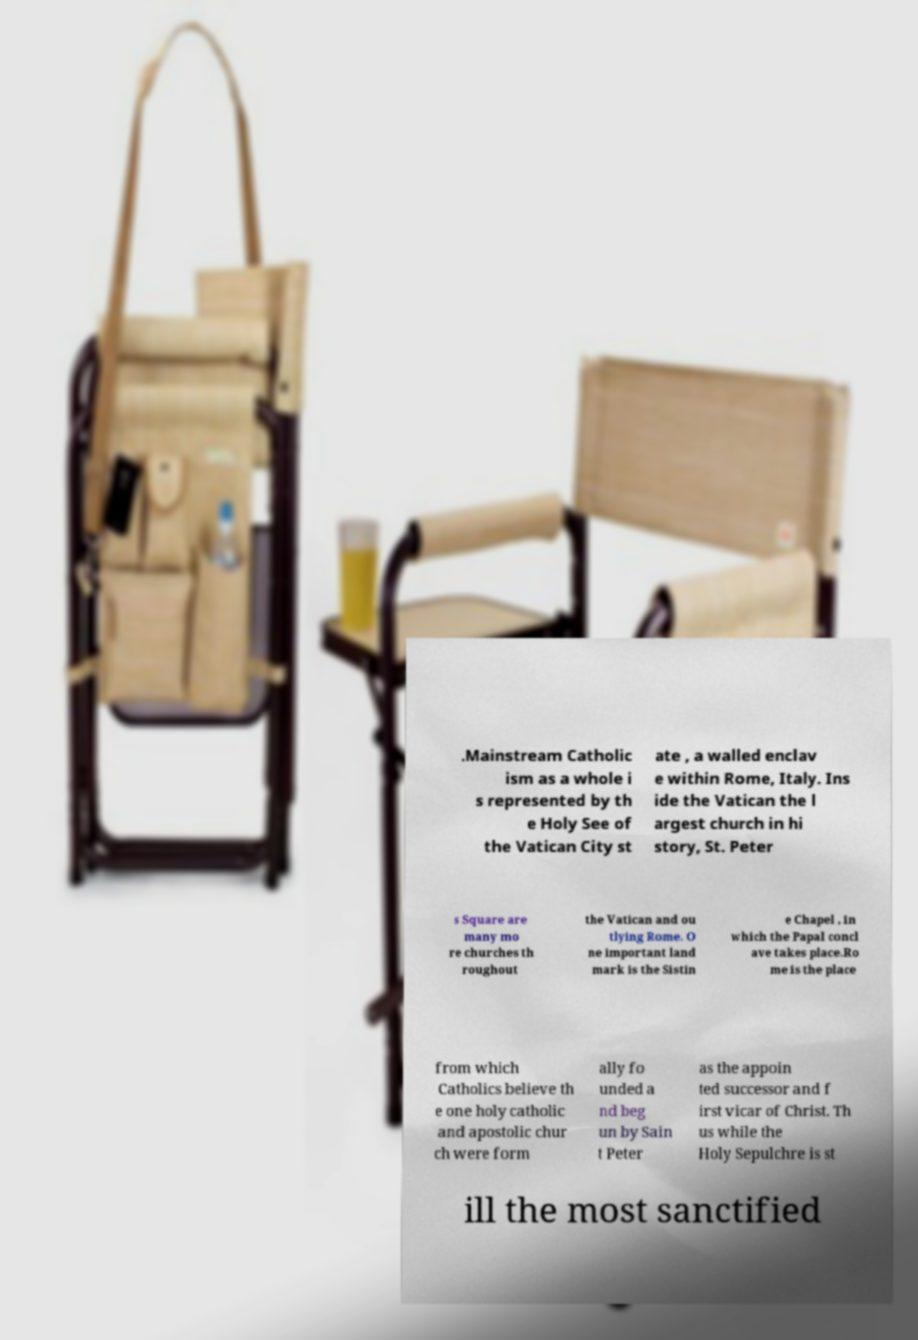Could you extract and type out the text from this image? .Mainstream Catholic ism as a whole i s represented by th e Holy See of the Vatican City st ate , a walled enclav e within Rome, Italy. Ins ide the Vatican the l argest church in hi story, St. Peter s Square are many mo re churches th roughout the Vatican and ou tlying Rome. O ne important land mark is the Sistin e Chapel , in which the Papal concl ave takes place.Ro me is the place from which Catholics believe th e one holy catholic and apostolic chur ch were form ally fo unded a nd beg un by Sain t Peter as the appoin ted successor and f irst vicar of Christ. Th us while the Holy Sepulchre is st ill the most sanctified 